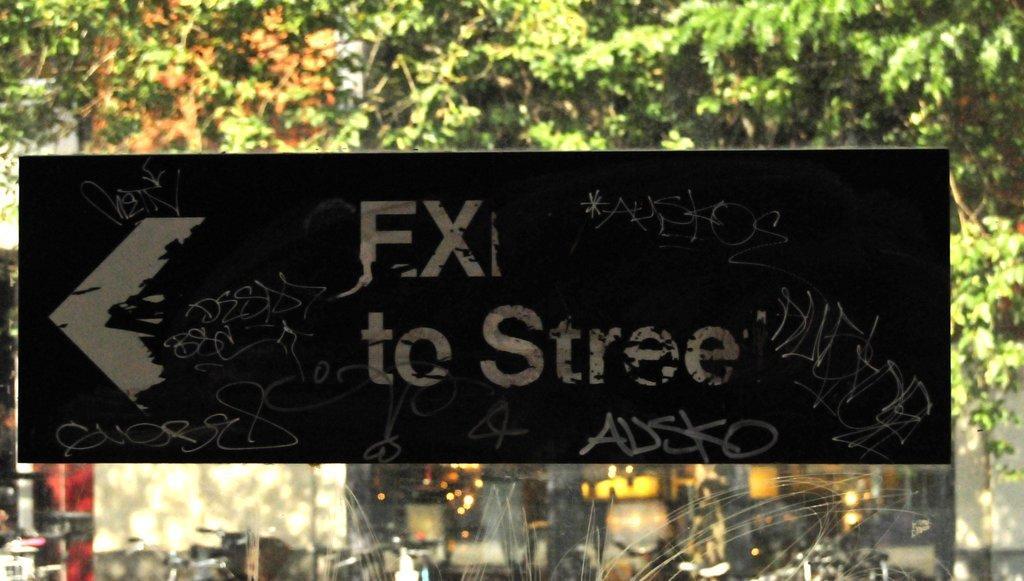Describe this image in one or two sentences. In this picture, we can see a blackboard and on the board it is written something. Behind the board there are trees and behind the tree, it looks like a building. 